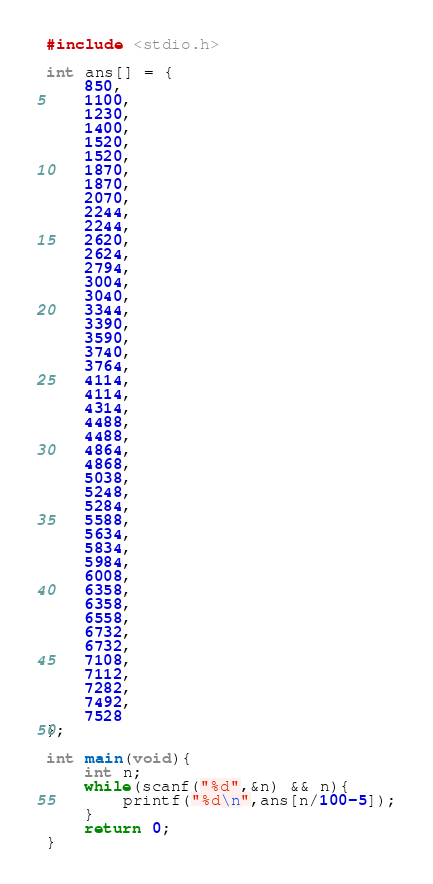<code> <loc_0><loc_0><loc_500><loc_500><_C_>#include <stdio.h>

int ans[] = {
	850,
	1100,
	1230,
	1400,
	1520,
	1520,
	1870,
	1870,
	2070,
	2244,
	2244,
	2620,
	2624,
	2794,
	3004,
	3040,
	3344,
	3390,
	3590,
	3740,
	3764,
	4114,
	4114,
	4314,
	4488,
	4488,
	4864,
	4868,
	5038,
	5248,
	5284,
	5588,
	5634,
	5834,
	5984,
	6008,
	6358,
	6358,
	6558,
	6732,
	6732,
	7108,
	7112,
	7282,
	7492,
	7528
};

int main(void){
	int n;
	while(scanf("%d",&n) && n){
		printf("%d\n",ans[n/100-5]);
	}
	return 0;
}</code> 